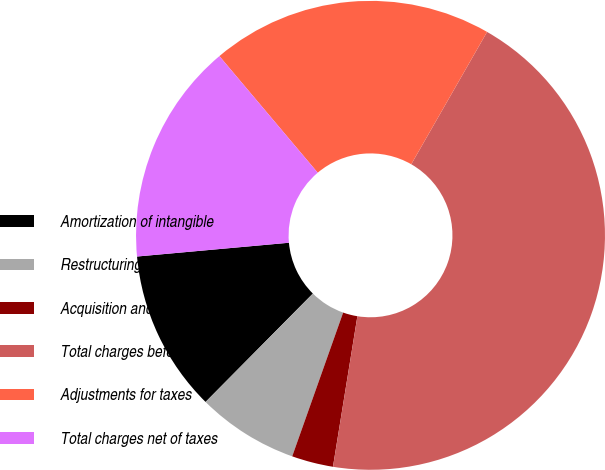<chart> <loc_0><loc_0><loc_500><loc_500><pie_chart><fcel>Amortization of intangible<fcel>Restructuring charges<fcel>Acquisition and other related<fcel>Total charges before taxes<fcel>Adjustments for taxes<fcel>Total charges net of taxes<nl><fcel>11.14%<fcel>7.0%<fcel>2.86%<fcel>44.28%<fcel>19.43%<fcel>15.29%<nl></chart> 